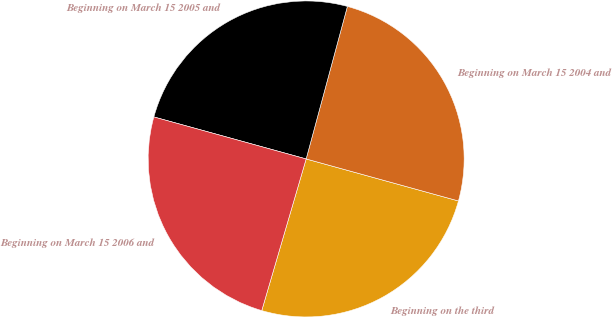Convert chart. <chart><loc_0><loc_0><loc_500><loc_500><pie_chart><fcel>Beginning on the third<fcel>Beginning on March 15 2004 and<fcel>Beginning on March 15 2005 and<fcel>Beginning on March 15 2006 and<nl><fcel>25.25%<fcel>25.08%<fcel>24.92%<fcel>24.75%<nl></chart> 